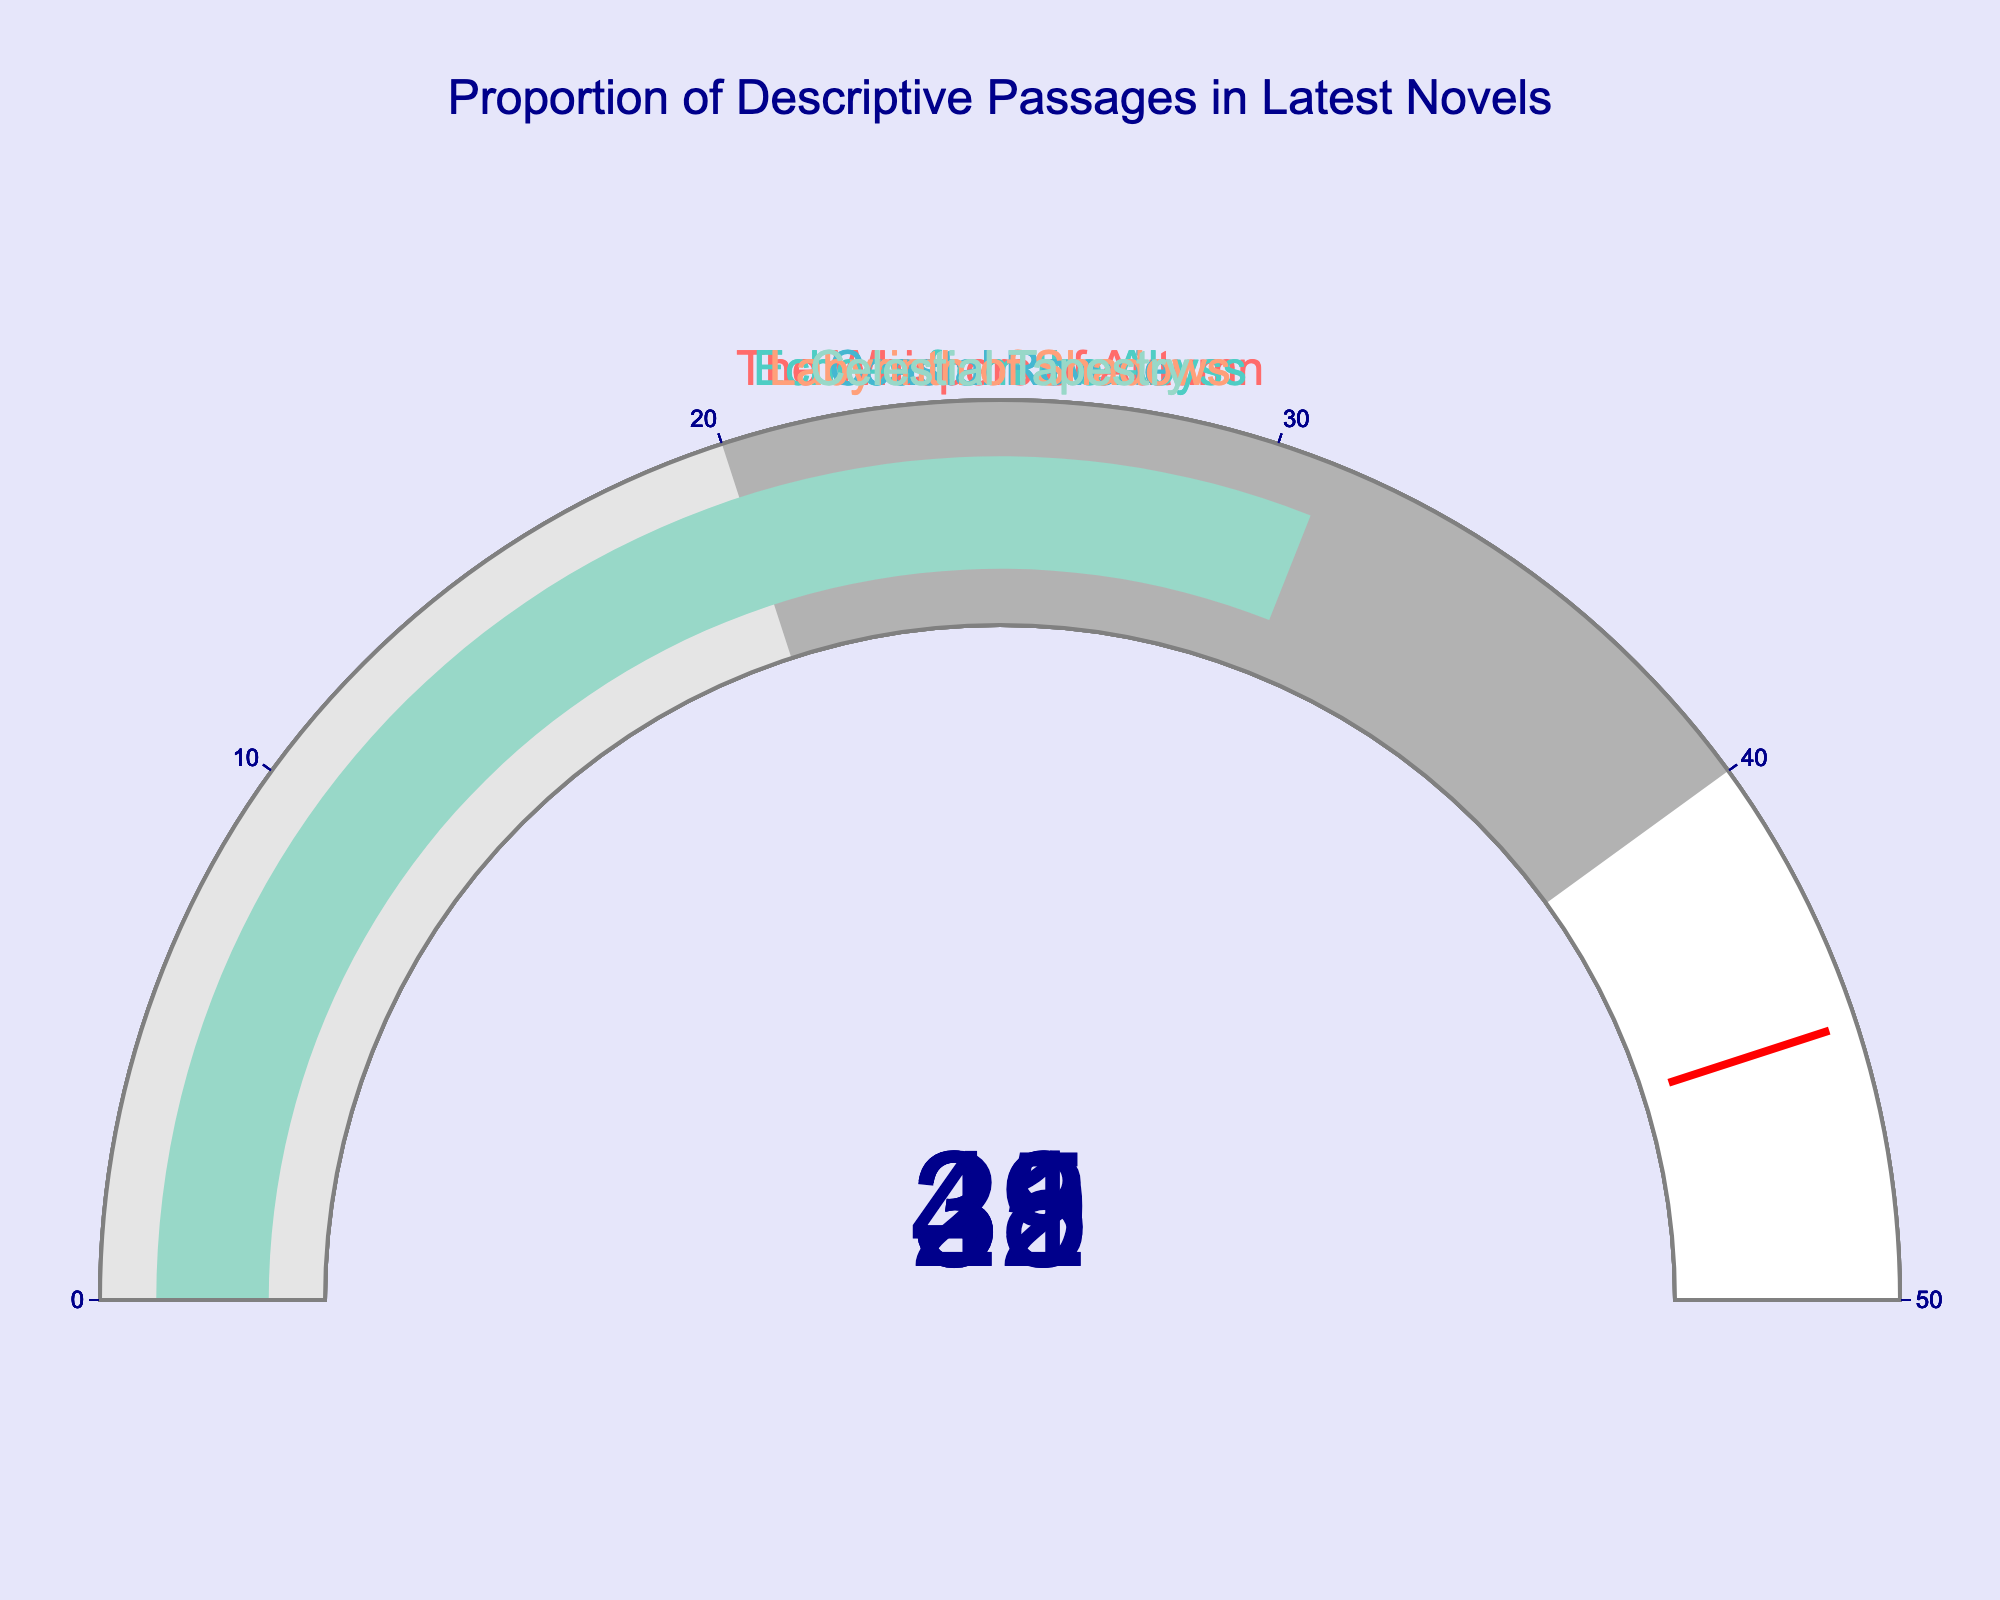What is the title of the chart? The title is usually found at the top or above the main visualization area. The title of the chart in this figure is stated in the middle top portion.
Answer: Proportion of Descriptive Passages in Latest Novels How many novels are represented on the chart? To find this, count the number of gauges on the figure. Each gauge represents one novel.
Answer: 5 Which novel has the highest proportion of descriptive passages? Look at the values on each gauge to identify the highest one. The novel associated with this gauge is the answer.
Answer: Echoes from the Abyss How does the proportion of descriptive passages in "Labyrinth of Shadows" compare to "Celestial Tapestry"? Locate the values for both novels and compare them. "Labyrinth of Shadows" has 39%, and "Celestial Tapestry" has 31%. 39% > 31%, so "Labyrinth of Shadows" has a higher proportion.
Answer: Labyrinth of Shadows has a higher proportion What is the average proportion of descriptive passages among all the novels? Calculate the sum of all the proportions (35 + 42 + 28 + 39 + 31) and divide by the number of novels (5). (35 + 42 + 28 + 39 + 31) / 5 = 35
Answer: 35% Which novels fall below the 30% mark in their proportion of descriptive passages? Check the values on each gauge and identify which ones are below 30%.
Answer: Coastal Reverie If we put "Celestial Tapestry" and "The Whispers of Autumn" together, what would be their combined proportion of descriptive passages? Sum up the respective values (31 + 35). 31 + 35 = 66
Answer: 66% What is the difference in the proportion of descriptive passages between the novel with the highest value and the one with the lowest? Identify the highest (42) and lowest (28) values and calculate the difference. 42 - 28 = 14
Answer: 14% Where is the threshold set for this gauge chart? The threshold indicator is a distinct visual element, typically denoted by a line or marker. Check the mentioned value on the indicator.
Answer: 45% 